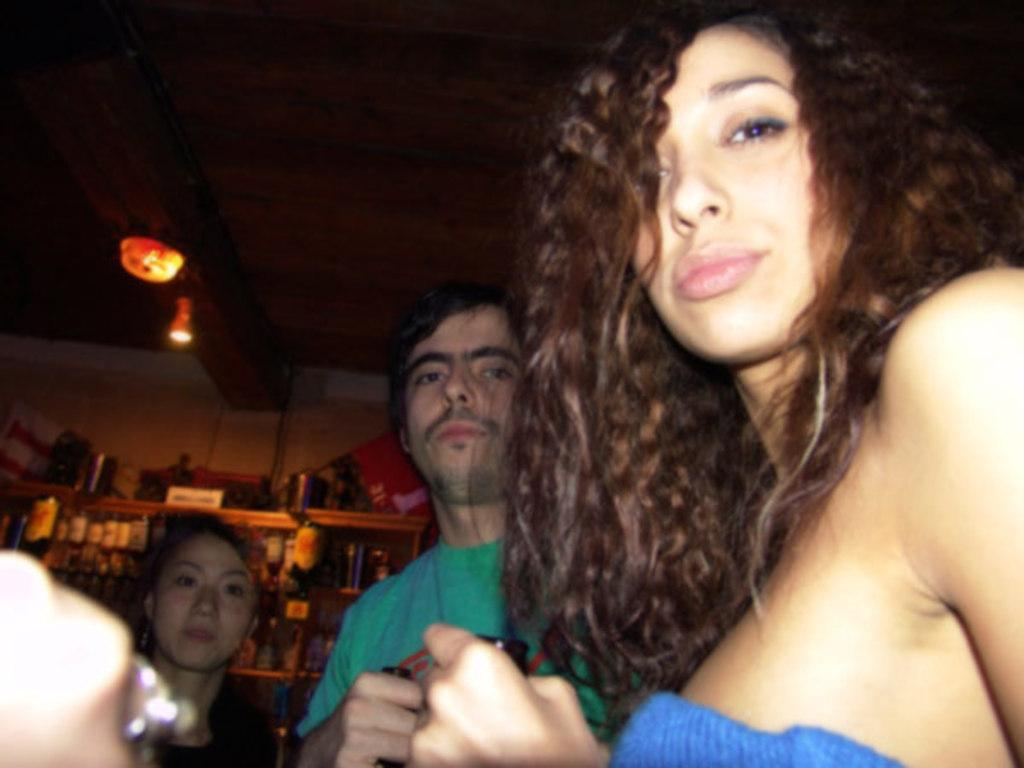Who or what is present in the image? There are people in the image. What can be seen on the shelves in the image? There are bottles on shelves in the image. What type of lighting is present in the image? There are lights on the ceiling in the image. What are some people doing with the bottles in the image? Some people are holding bottles in their hands. Can you see a chess game being played in the image? There is no chess game visible in the image. How many ducks are present in the image? There are no ducks present in the image. 